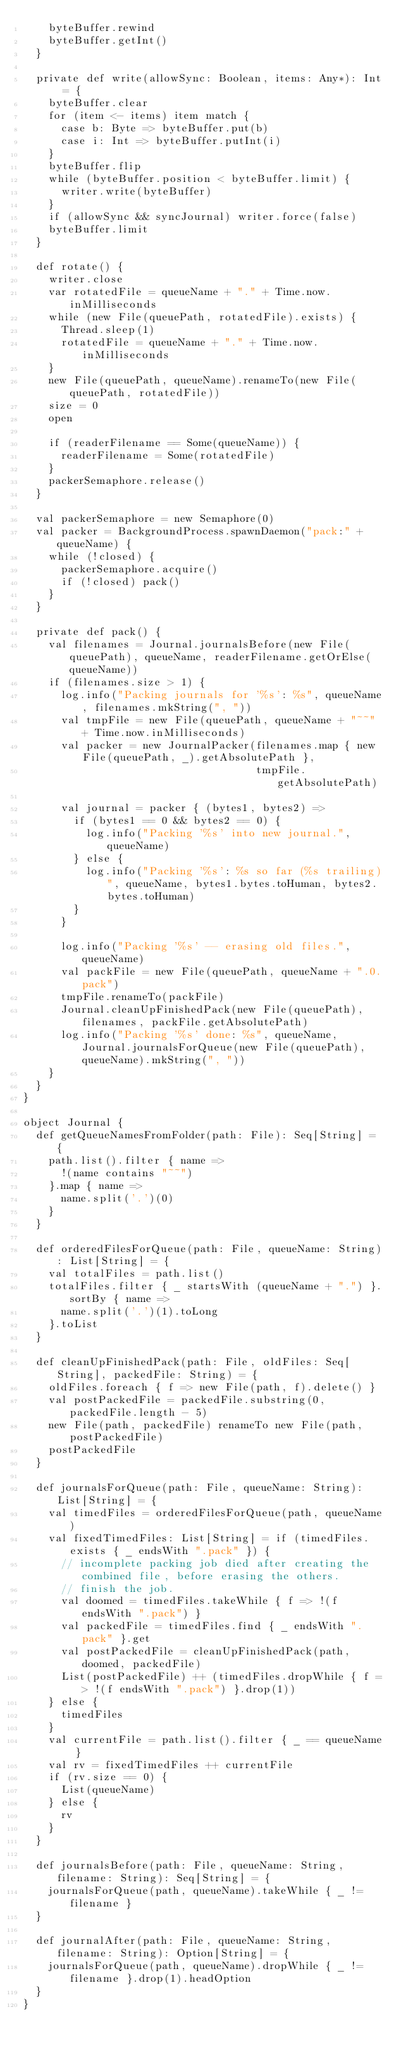Convert code to text. <code><loc_0><loc_0><loc_500><loc_500><_Scala_>    byteBuffer.rewind
    byteBuffer.getInt()
  }

  private def write(allowSync: Boolean, items: Any*): Int = {
    byteBuffer.clear
    for (item <- items) item match {
      case b: Byte => byteBuffer.put(b)
      case i: Int => byteBuffer.putInt(i)
    }
    byteBuffer.flip
    while (byteBuffer.position < byteBuffer.limit) {
      writer.write(byteBuffer)
    }
    if (allowSync && syncJournal) writer.force(false)
    byteBuffer.limit
  }

  def rotate() {
    writer.close
    var rotatedFile = queueName + "." + Time.now.inMilliseconds
    while (new File(queuePath, rotatedFile).exists) {
      Thread.sleep(1)
      rotatedFile = queueName + "." + Time.now.inMilliseconds
    }
    new File(queuePath, queueName).renameTo(new File(queuePath, rotatedFile))
    size = 0
    open

    if (readerFilename == Some(queueName)) {
      readerFilename = Some(rotatedFile)
    }
    packerSemaphore.release()
  }

  val packerSemaphore = new Semaphore(0)
  val packer = BackgroundProcess.spawnDaemon("pack:" + queueName) {
    while (!closed) {
      packerSemaphore.acquire()
      if (!closed) pack()
    }
  }

  private def pack() {
    val filenames = Journal.journalsBefore(new File(queuePath), queueName, readerFilename.getOrElse(queueName))
    if (filenames.size > 1) {
      log.info("Packing journals for '%s': %s", queueName, filenames.mkString(", "))
      val tmpFile = new File(queuePath, queueName + "~~" + Time.now.inMilliseconds)
      val packer = new JournalPacker(filenames.map { new File(queuePath, _).getAbsolutePath },
                                     tmpFile.getAbsolutePath)

      val journal = packer { (bytes1, bytes2) =>
        if (bytes1 == 0 && bytes2 == 0) {
          log.info("Packing '%s' into new journal.", queueName)
        } else {
          log.info("Packing '%s': %s so far (%s trailing)", queueName, bytes1.bytes.toHuman, bytes2.bytes.toHuman)
        }
      }

      log.info("Packing '%s' -- erasing old files.", queueName)
      val packFile = new File(queuePath, queueName + ".0.pack")
      tmpFile.renameTo(packFile)
      Journal.cleanUpFinishedPack(new File(queuePath), filenames, packFile.getAbsolutePath)
      log.info("Packing '%s' done: %s", queueName, Journal.journalsForQueue(new File(queuePath), queueName).mkString(", "))
    }
  }
}

object Journal {
  def getQueueNamesFromFolder(path: File): Seq[String] = {
    path.list().filter { name =>
      !(name contains "~~")
    }.map { name =>
      name.split('.')(0)
    }
  }

  def orderedFilesForQueue(path: File, queueName: String): List[String] = {
    val totalFiles = path.list()
    totalFiles.filter { _ startsWith (queueName + ".") }.sortBy { name =>
      name.split('.')(1).toLong
    }.toList
  }

  def cleanUpFinishedPack(path: File, oldFiles: Seq[String], packedFile: String) = {
    oldFiles.foreach { f => new File(path, f).delete() }
    val postPackedFile = packedFile.substring(0, packedFile.length - 5)
    new File(path, packedFile) renameTo new File(path, postPackedFile)
    postPackedFile
  }

  def journalsForQueue(path: File, queueName: String): List[String] = {
    val timedFiles = orderedFilesForQueue(path, queueName)
    val fixedTimedFiles: List[String] = if (timedFiles.exists { _ endsWith ".pack" }) {
      // incomplete packing job died after creating the combined file, before erasing the others.
      // finish the job.
      val doomed = timedFiles.takeWhile { f => !(f endsWith ".pack") }
      val packedFile = timedFiles.find { _ endsWith ".pack" }.get
      val postPackedFile = cleanUpFinishedPack(path, doomed, packedFile)
      List(postPackedFile) ++ (timedFiles.dropWhile { f => !(f endsWith ".pack") }.drop(1))
    } else {
      timedFiles
    }
    val currentFile = path.list().filter { _ == queueName }
    val rv = fixedTimedFiles ++ currentFile
    if (rv.size == 0) {
      List(queueName)
    } else {
      rv
    }
  }

  def journalsBefore(path: File, queueName: String, filename: String): Seq[String] = {
    journalsForQueue(path, queueName).takeWhile { _ != filename }
  }

  def journalAfter(path: File, queueName: String, filename: String): Option[String] = {
    journalsForQueue(path, queueName).dropWhile { _ != filename }.drop(1).headOption
  }
}
</code> 